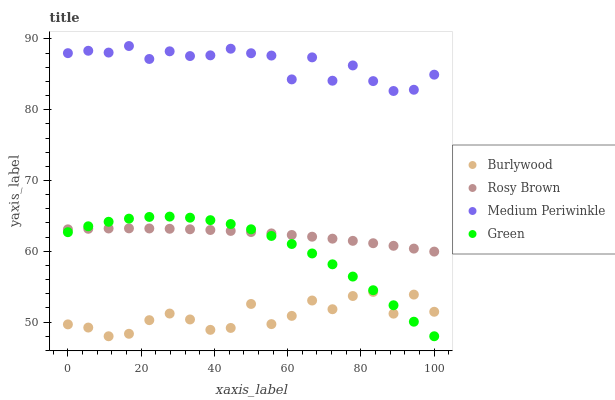Does Burlywood have the minimum area under the curve?
Answer yes or no. Yes. Does Medium Periwinkle have the maximum area under the curve?
Answer yes or no. Yes. Does Green have the minimum area under the curve?
Answer yes or no. No. Does Green have the maximum area under the curve?
Answer yes or no. No. Is Rosy Brown the smoothest?
Answer yes or no. Yes. Is Burlywood the roughest?
Answer yes or no. Yes. Is Green the smoothest?
Answer yes or no. No. Is Green the roughest?
Answer yes or no. No. Does Burlywood have the lowest value?
Answer yes or no. Yes. Does Rosy Brown have the lowest value?
Answer yes or no. No. Does Medium Periwinkle have the highest value?
Answer yes or no. Yes. Does Green have the highest value?
Answer yes or no. No. Is Burlywood less than Medium Periwinkle?
Answer yes or no. Yes. Is Medium Periwinkle greater than Green?
Answer yes or no. Yes. Does Rosy Brown intersect Green?
Answer yes or no. Yes. Is Rosy Brown less than Green?
Answer yes or no. No. Is Rosy Brown greater than Green?
Answer yes or no. No. Does Burlywood intersect Medium Periwinkle?
Answer yes or no. No. 